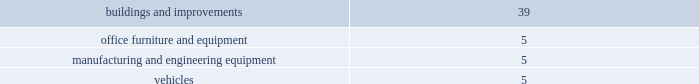
Long-lived assets in accordance with sfas no .
144 , accounting for the impairment or disposal of long-lived assets , the company reviews long-lived assets for impairment whenever events or changes in circumstances indicate the carrying amount of an asset may not be fully recoverable .
The carrying amount of a long-lived asset is not recoverable if it exceeds the sum of the undiscounted cash flows expected to result from the use and eventual disposition of the asset .
That assessment is based on the carrying amount of the asset at the date it is tested for recoverability .
An impairment loss is measured as the amount by which the carrying amount of a long-lived asset exceeds its fair value .
Sfas no .
142 , goodwill and other intangible assets , requires that goodwill and intangible assets with indefinite useful lives should not be amortized but rather be tested for impairment at least annually or sooner whenever events or changes in circumstances indicate that they may be impaired .
The company did not recognize any goodwill or intangible asset impairment charges in 2008 , 2007 , or 2006 .
The company established reporting units based on its current reporting structure .
For purposes of testing goodwill for impairment , goodwill has been allocated to these reporting units to the extent it relates to each reporting unit .
Sfas no .
142 also requires that intangible assets with definite lives be amortized over their estimated useful lives and reviewed for impairment in accordance with sfas no .
144 .
The company is currently amortizing its acquired intangible assets with definite lives over periods ranging from 3 to 10 years .
Dividends on june 6 , 2008 the board of directors declared a dividend of $ 0.75 per share to be paid on december 15 , 2008 to shareholders of record on december 1 , 2008 .
The company paid out a dividend in the amount of $ 150251 .
The dividend has been reported as a reduction of retained earnings .
On august 1 , 2007 the board of directors declared a dividend of $ 0.75 per share to be paid on september 14 , 2007 to shareholders of record on august 15 , 2007 .
The company paid out a dividend in the amount of $ 162531 .
The dividend has been reported as a reduction of retained earnings .
On april 26 , 2006 the board of directors declared a post-split dividend of $ 0.50 per share to be paid on december 15 , 2006 to shareholders of record on december 1 , 2006 .
The company paid out a dividend in the amount of $ 107923 .
The dividend has been reported as a reduction of retained earnings .
Approximately $ 186383 and $ 159210 of retained earnings are indefinitely restricted from distribution to stockholders pursuant to the laws of taiwan at december 27 , 2008 and december 29 , 2007 , respectively .
Intangible assets at december 27 , 2008 and december 29 , 2007 , the company had patents , license agreements , customer related intangibles and other identifiable finite-lived intangible assets recorded at a cost of $ 152104 and $ 159503 , respectively .
The company 2019s excess purchase cost over fair value of net assets acquired ( goodwill ) was $ 127429 at december 27 , 2008 and $ 98494 at december 29 , 2007 .
Identifiable , finite-lived intangible assets are amortized over their estimated useful lives on a straight-line basis over three to ten years .
Accumulated amortization was $ 48579 and $ 59967 at december 27 , 2008 and december 29 , 2007 respectively .
Amortization expense was $ 30874 , $ 26942 , and $ 21147 , for the years ended .
What is the ratio between the value of vehicles and buildings and improvements? 
Rationale: it is the value of the vehicles divided by the value of the buildings and improvements .
Computations: (5 / 39)
Answer: 0.12821. 